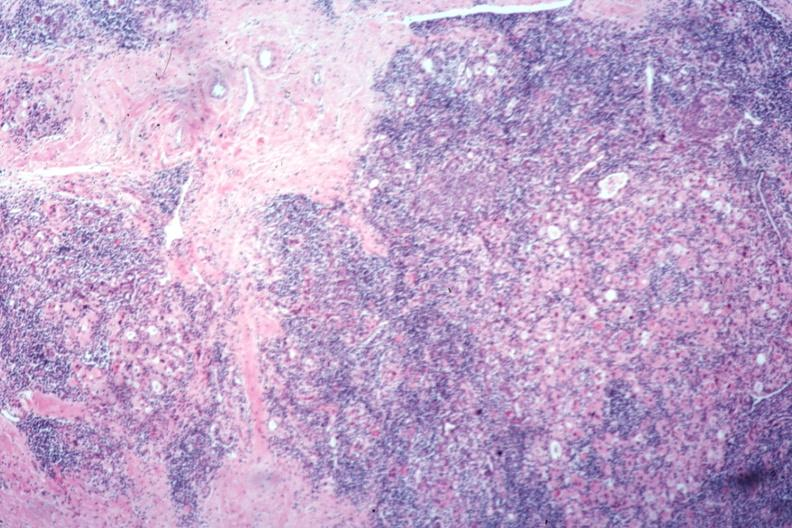does this image show typical severe hashimotos no thyroid tissue recognizable?
Answer the question using a single word or phrase. Yes 